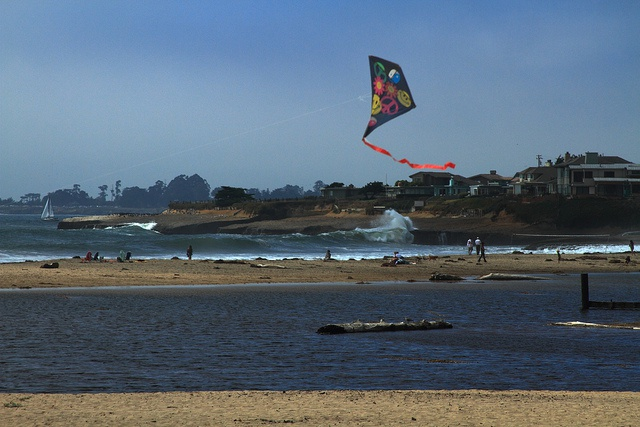Describe the objects in this image and their specific colors. I can see kite in darkgray, black, gray, and purple tones, boat in darkgray, black, gray, and navy tones, boat in darkgray, gray, and blue tones, people in darkgray, black, and gray tones, and people in darkgray, black, gray, and maroon tones in this image. 